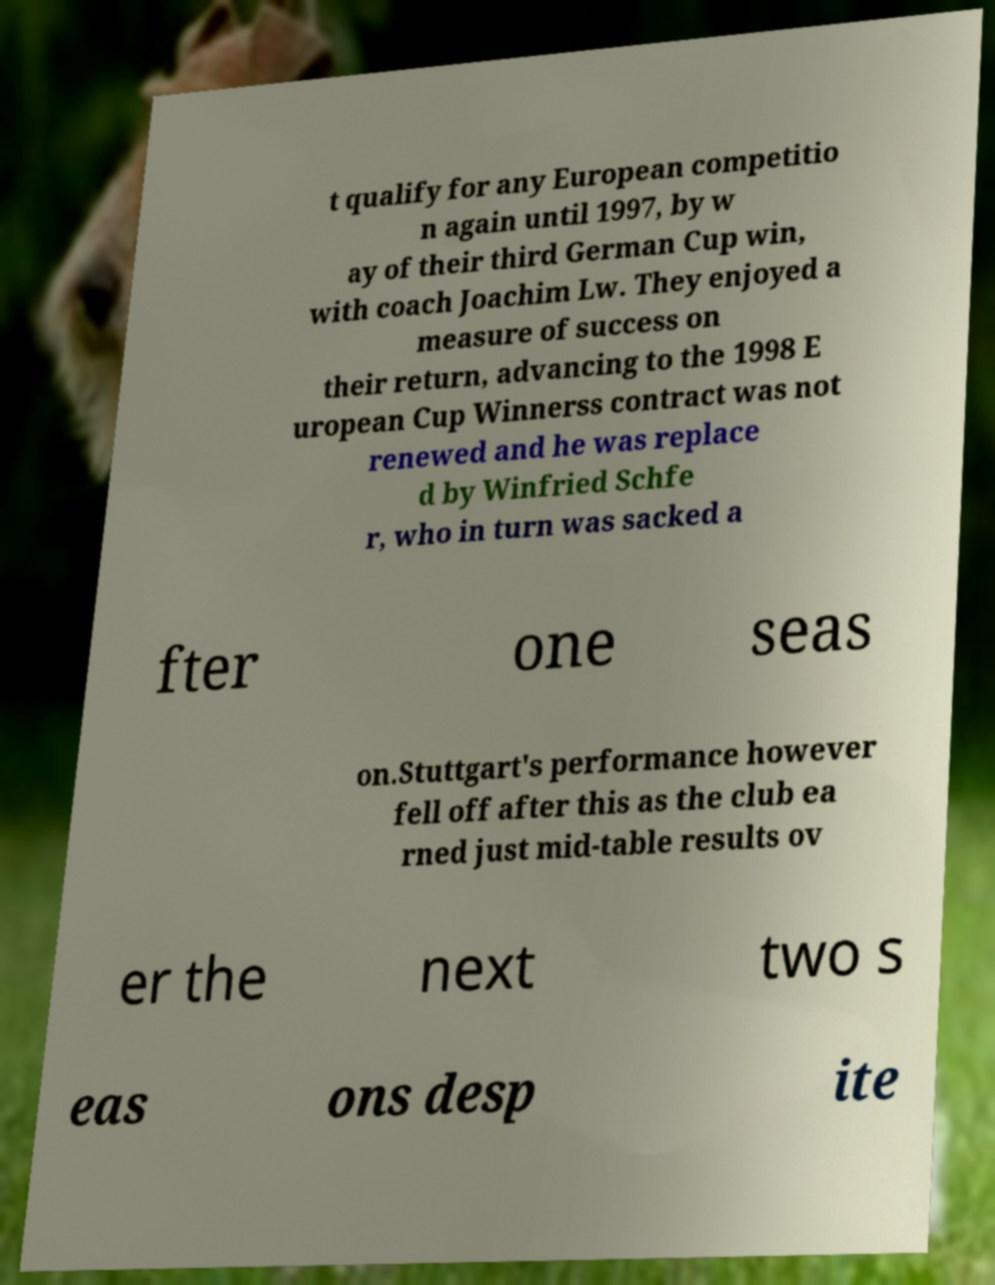What messages or text are displayed in this image? I need them in a readable, typed format. t qualify for any European competitio n again until 1997, by w ay of their third German Cup win, with coach Joachim Lw. They enjoyed a measure of success on their return, advancing to the 1998 E uropean Cup Winnerss contract was not renewed and he was replace d by Winfried Schfe r, who in turn was sacked a fter one seas on.Stuttgart's performance however fell off after this as the club ea rned just mid-table results ov er the next two s eas ons desp ite 